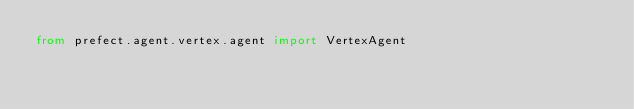<code> <loc_0><loc_0><loc_500><loc_500><_Python_>from prefect.agent.vertex.agent import VertexAgent
</code> 